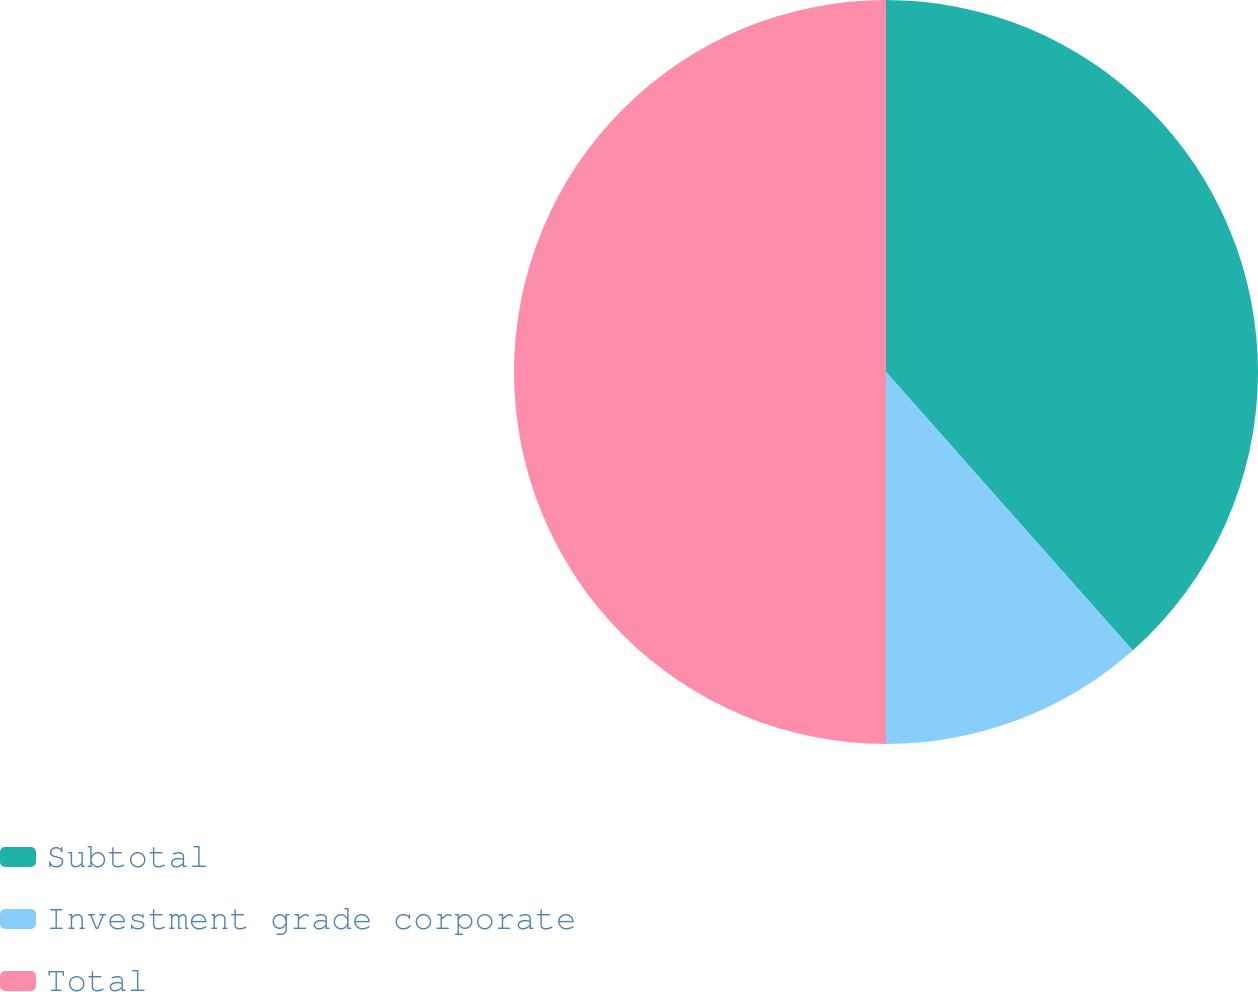Convert chart. <chart><loc_0><loc_0><loc_500><loc_500><pie_chart><fcel>Subtotal<fcel>Investment grade corporate<fcel>Total<nl><fcel>38.46%<fcel>11.54%<fcel>50.0%<nl></chart> 